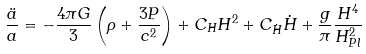<formula> <loc_0><loc_0><loc_500><loc_500>\frac { \ddot { a } } { a } = - \frac { 4 \pi G } { 3 } \left ( \rho + \frac { 3 P } { c ^ { 2 } } \right ) + C _ { H } H ^ { 2 } + C _ { \dot { H } } \dot { H } + \frac { g } { \pi } \frac { H ^ { 4 } } { H _ { P l } ^ { 2 } }</formula> 